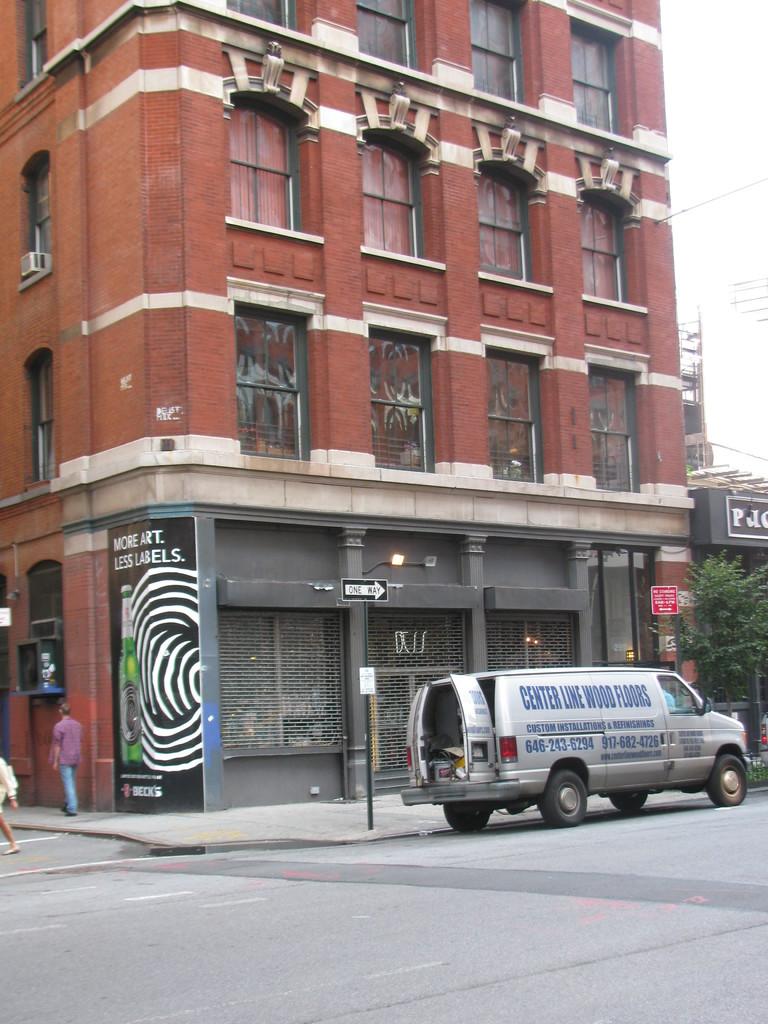What is written on the van?
Provide a short and direct response. Center line wood floors. What does the painting on the wall say?
Give a very brief answer. More art less labels. 